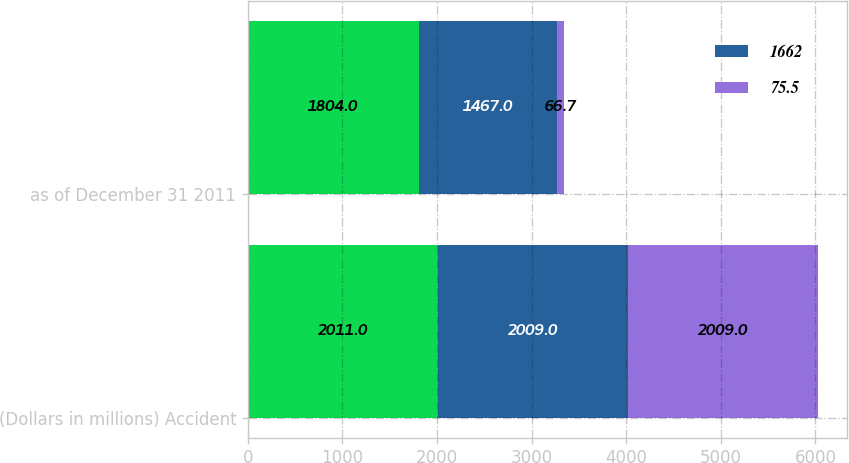Convert chart. <chart><loc_0><loc_0><loc_500><loc_500><stacked_bar_chart><ecel><fcel>(Dollars in millions) Accident<fcel>as of December 31 2011<nl><fcel>nan<fcel>2011<fcel>1804<nl><fcel>1662<fcel>2009<fcel>1467<nl><fcel>75.5<fcel>2009<fcel>66.7<nl></chart> 